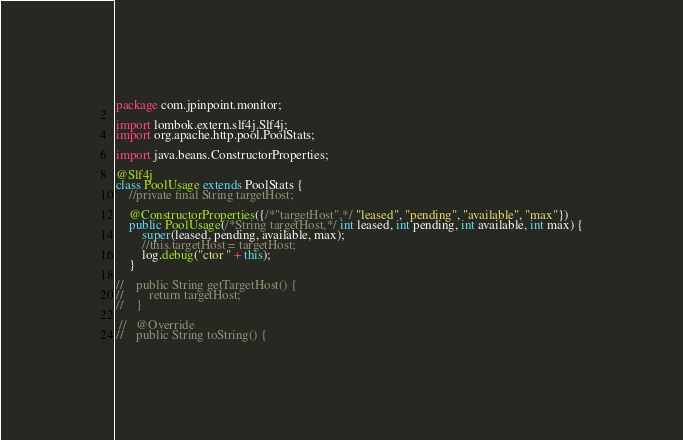Convert code to text. <code><loc_0><loc_0><loc_500><loc_500><_Java_>package com.jpinpoint.monitor;

import lombok.extern.slf4j.Slf4j;
import org.apache.http.pool.PoolStats;

import java.beans.ConstructorProperties;

@Slf4j
class PoolUsage extends PoolStats {
    //private final String targetHost;

    @ConstructorProperties({/*"targetHost",*/ "leased", "pending", "available", "max"})
    public PoolUsage(/*String targetHost,*/ int leased, int pending, int available, int max) {
        super(leased, pending, available, max);
        //this.targetHost = targetHost;
        log.debug("ctor " + this);
    }

//    public String getTargetHost() {
//        return targetHost;
//    }

 //   @Override
//    public String toString() {</code> 